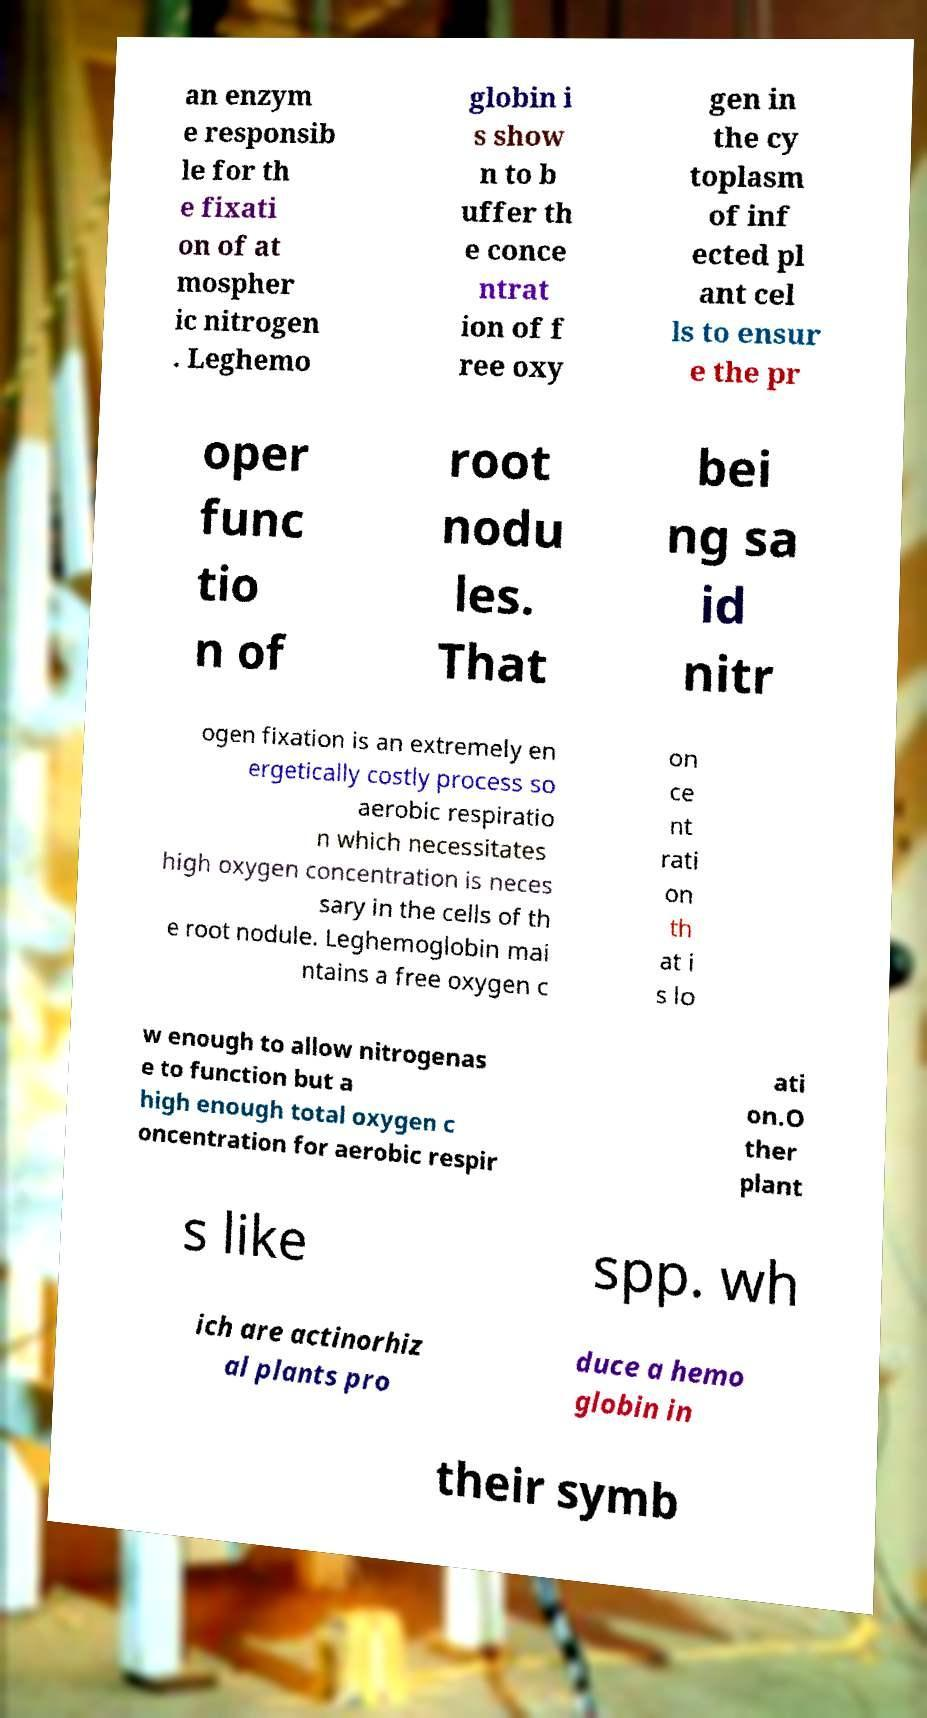Please identify and transcribe the text found in this image. an enzym e responsib le for th e fixati on of at mospher ic nitrogen . Leghemo globin i s show n to b uffer th e conce ntrat ion of f ree oxy gen in the cy toplasm of inf ected pl ant cel ls to ensur e the pr oper func tio n of root nodu les. That bei ng sa id nitr ogen fixation is an extremely en ergetically costly process so aerobic respiratio n which necessitates high oxygen concentration is neces sary in the cells of th e root nodule. Leghemoglobin mai ntains a free oxygen c on ce nt rati on th at i s lo w enough to allow nitrogenas e to function but a high enough total oxygen c oncentration for aerobic respir ati on.O ther plant s like spp. wh ich are actinorhiz al plants pro duce a hemo globin in their symb 